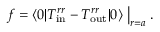<formula> <loc_0><loc_0><loc_500><loc_500>f = \langle 0 | T _ { i n } ^ { r r } - T _ { o u t } ^ { r r } | 0 \rangle \Big | _ { r = a } .</formula> 